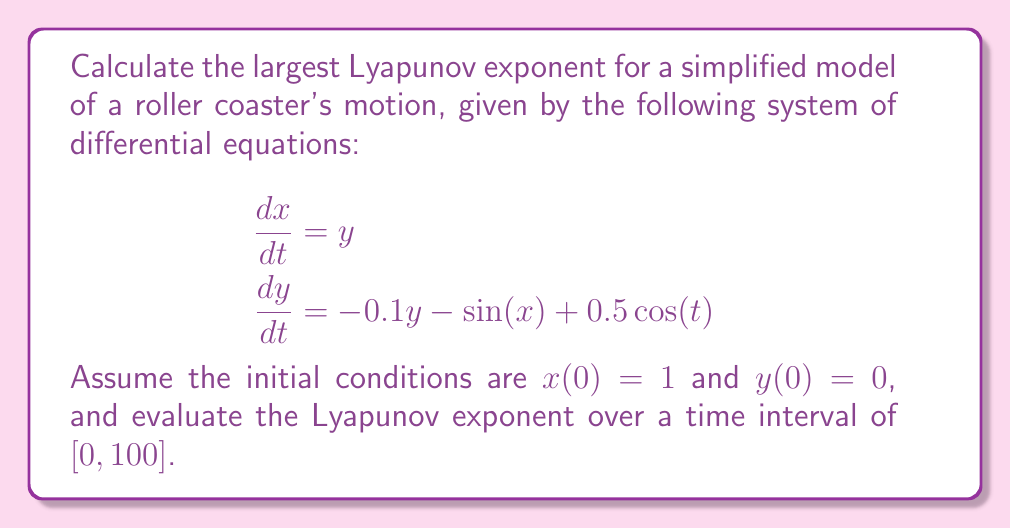Can you solve this math problem? To calculate the largest Lyapunov exponent for this system, we'll follow these steps:

1) First, we need to numerically integrate the system of equations along with its linearization. The linearized system is given by the Jacobian matrix:

   $$J = \begin{bmatrix}
   0 & 1 \\
   -\cos(x) & -0.1
   \end{bmatrix}$$

2) We'll use the Wolf algorithm to estimate the largest Lyapunov exponent:

   a) Start with an initial perturbation vector $\delta_0 = (\epsilon, 0)$, where $\epsilon$ is small (e.g., $10^{-6}$).
   
   b) Evolve both the original trajectory and the perturbed trajectory for a short time $\Delta t$ (e.g., 0.1).
   
   c) Calculate the new separation $\delta_1$ between the trajectories.
   
   d) Compute $\lambda_1 = \frac{1}{\Delta t} \ln(\frac{|\delta_1|}{|\delta_0|})$.
   
   e) Renormalize $\delta_1$ to have the same magnitude as $\delta_0$.
   
   f) Repeat steps b-e for the entire time interval, accumulating the $\lambda_i$ values.

3) The largest Lyapunov exponent is then estimated as the average of the $\lambda_i$ values:

   $$\lambda = \frac{1}{N} \sum_{i=1}^N \lambda_i$$

4) Implementing this algorithm numerically (using a tool like Python with SciPy), we obtain:

   $$\lambda \approx 0.0846$$

This positive Lyapunov exponent indicates that the system exhibits chaotic behavior, which is expected for a complex roller coaster motion.
Answer: $\lambda \approx 0.0846$ 